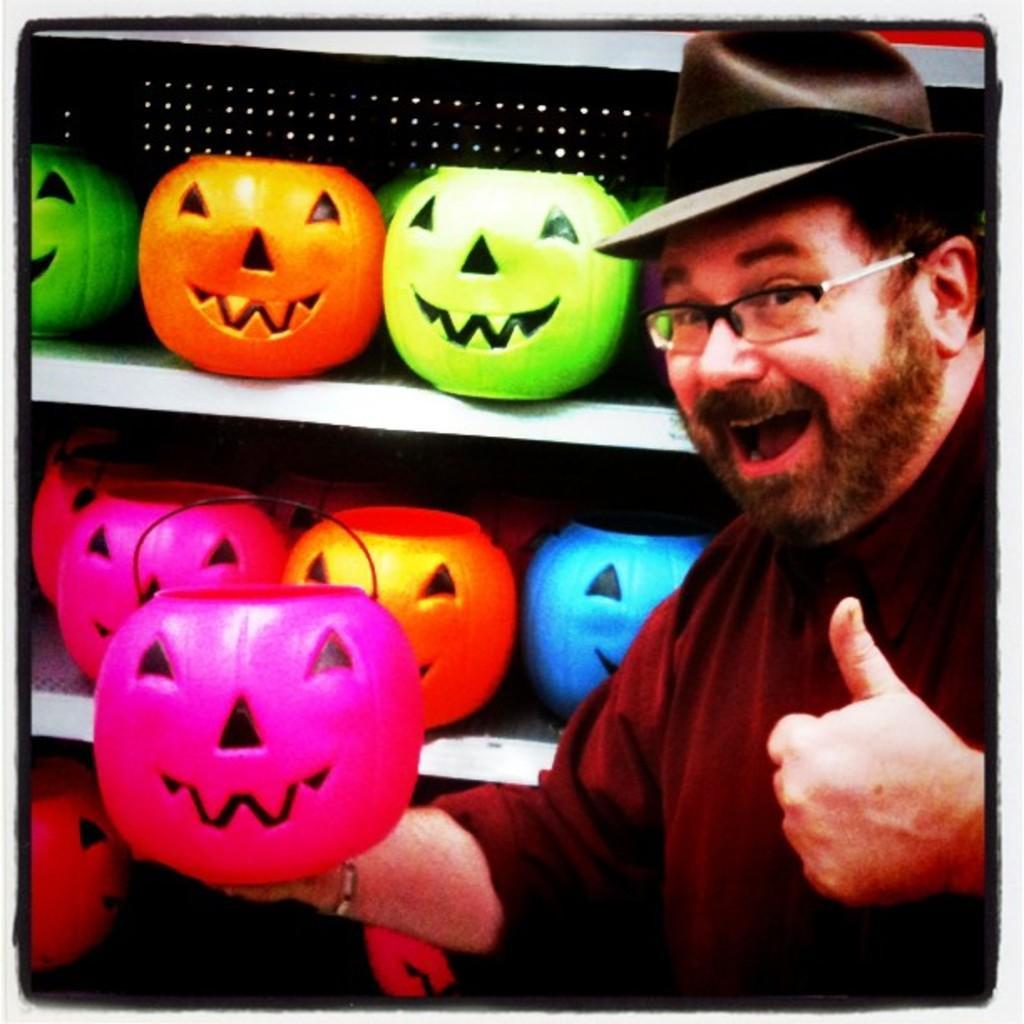Please provide a concise description of this image. In this image I can see a person wearing pink colored t shirt and black colored hat is holding a pink colored pumpkin. In the background I can see few other pumpkins in the racks. 